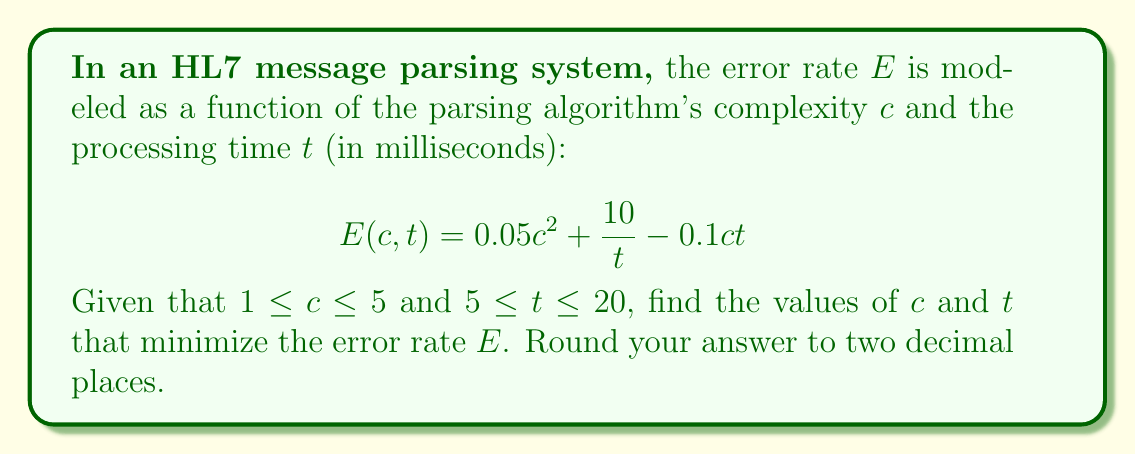Can you solve this math problem? To minimize the error rate $E(c,t)$, we need to find the values of $c$ and $t$ that satisfy the given constraints and result in the lowest possible value of $E$. This is a constrained optimization problem.

1. First, let's find the partial derivatives of $E$ with respect to $c$ and $t$:

   $$\frac{\partial E}{\partial c} = 0.1c - 0.1t$$
   $$\frac{\partial E}{\partial t} = -\frac{10}{t^2} - 0.1c$$

2. Set both partial derivatives to zero to find the critical points:

   $$0.1c - 0.1t = 0$$
   $$-\frac{10}{t^2} - 0.1c = 0$$

3. From the first equation:
   $$c = t$$

4. Substituting this into the second equation:
   $$-\frac{10}{t^2} - 0.1t = 0$$
   $$-10 - 0.1t^3 = 0$$
   $$t^3 = -100$$
   $$t = -4.64$$

5. However, this value of $t$ is outside our constraint of $5 \leq t \leq 20$. This means the minimum must occur at one of the boundaries of our constraints.

6. Let's evaluate $E(c,t)$ at the corners of our constraint region:
   - $E(1, 5) = 0.05 + 2 - 0.5 = 1.55$
   - $E(1, 20) = 0.05 + 0.5 - 2 = -1.45$
   - $E(5, 5) = 1.25 + 2 - 2.5 = 0.75$
   - $E(5, 20) = 1.25 + 0.5 - 10 = -8.25$

7. The minimum value occurs at $c = 5$ and $t = 20$, giving $E(5, 20) = -8.25$.

Therefore, the error rate is minimized when the parsing algorithm complexity $c$ is 5 and the processing time $t$ is 20 milliseconds.
Answer: $c = 5.00$, $t = 20.00$ ms 